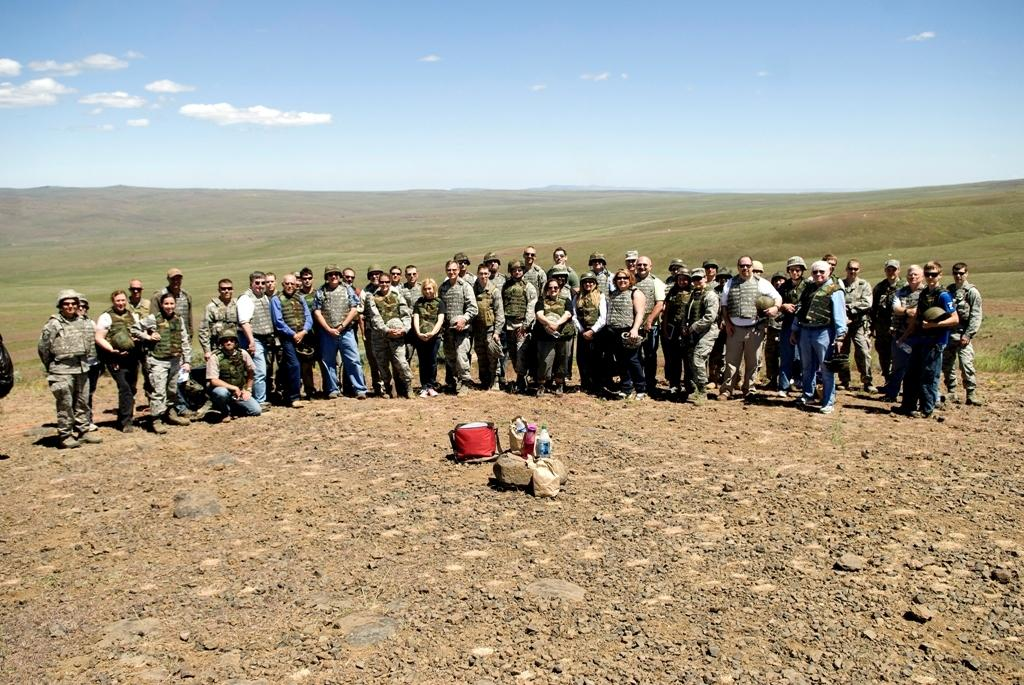How many people are in the image? There is a group of persons in the image. What are the people in the image doing? The persons are standing and smiling. What can be seen on the ground in the center of the image? There are objects on the ground in the center of the image. What type of vegetation is visible in the background? There is grass on the ground in the background. What is the condition of the sky in the image? The sky is cloudy in the image. What type of country can be seen in the image? There is no country visible in the image; it features a group of people standing and smiling. What is the temperature like in the image? The temperature is not mentioned in the image, but the sky being cloudy suggests it could be cooler. 